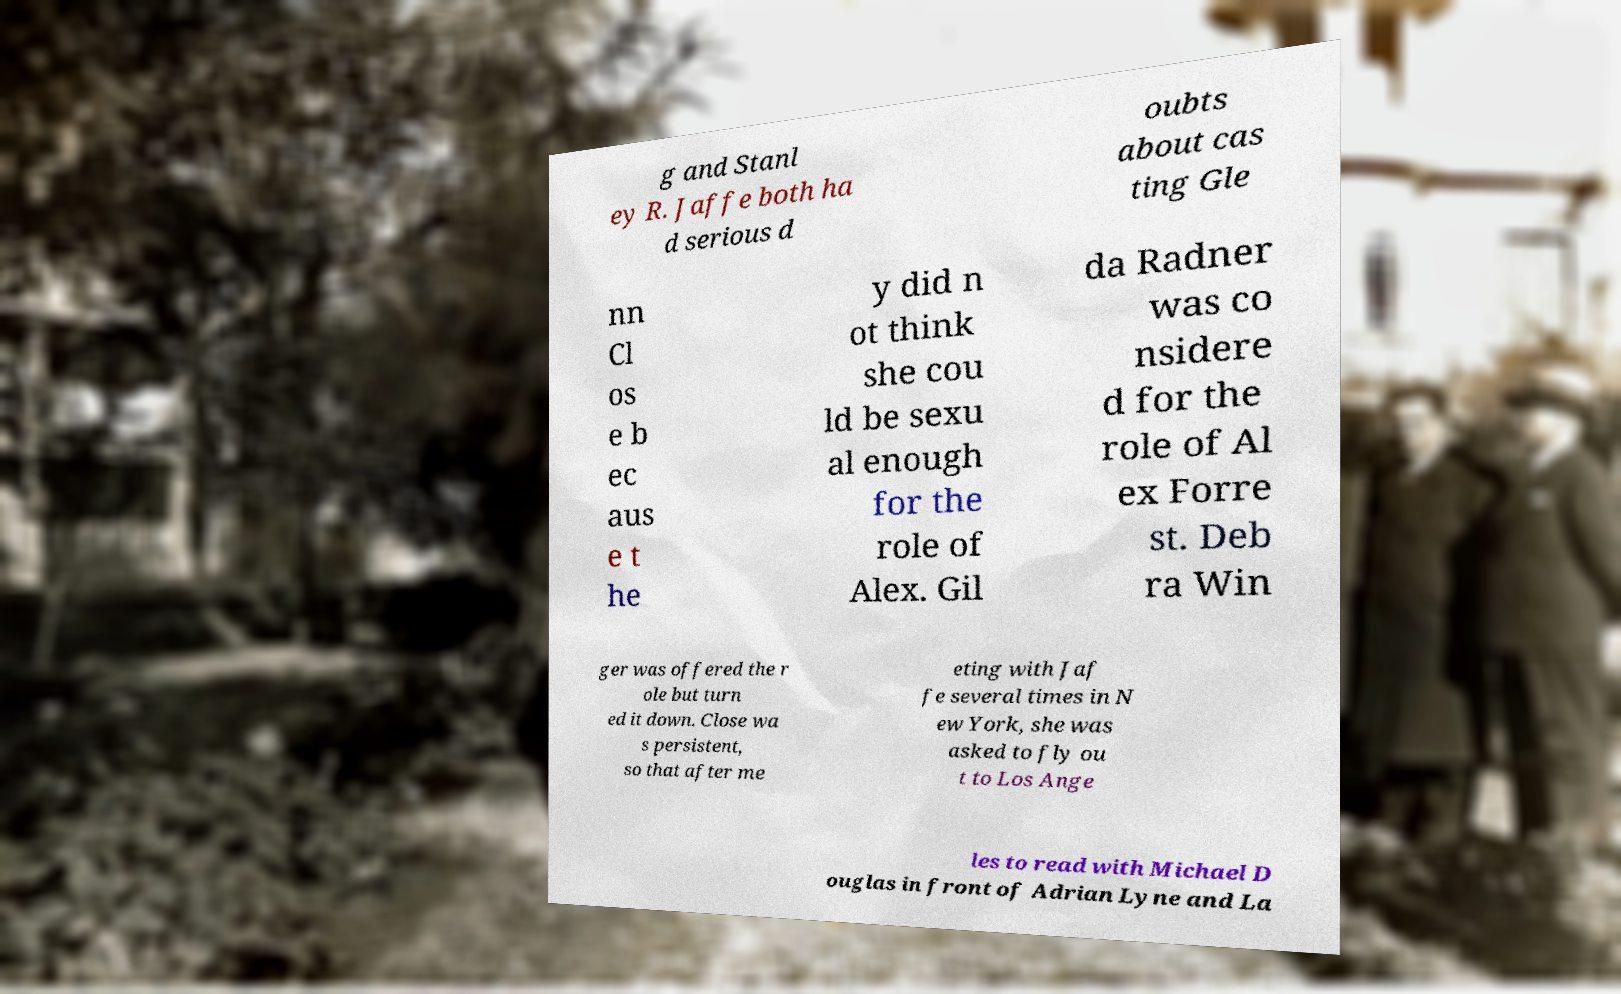What messages or text are displayed in this image? I need them in a readable, typed format. g and Stanl ey R. Jaffe both ha d serious d oubts about cas ting Gle nn Cl os e b ec aus e t he y did n ot think she cou ld be sexu al enough for the role of Alex. Gil da Radner was co nsidere d for the role of Al ex Forre st. Deb ra Win ger was offered the r ole but turn ed it down. Close wa s persistent, so that after me eting with Jaf fe several times in N ew York, she was asked to fly ou t to Los Ange les to read with Michael D ouglas in front of Adrian Lyne and La 